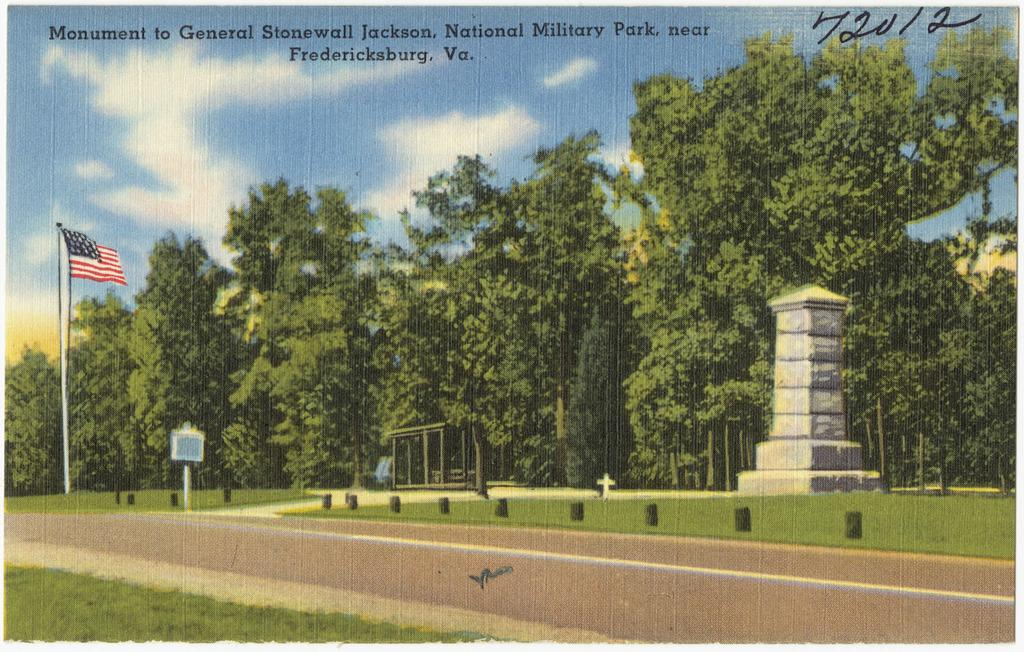What is the main object in the left corner of the image? There is a flag in the left corner of the image. How is the flag attached to the pole? The flag is attached to a pole. What can be seen in the background of the image? There are trees in the background of the image. Is there any text or writing associated with the flag? Yes, there is text or writing above the flag. What is the name of the son of the manager in the image? There is no mention of a son or a manager in the image; it only features a flag, a pole, trees in the background, and text or writing above the flag. 